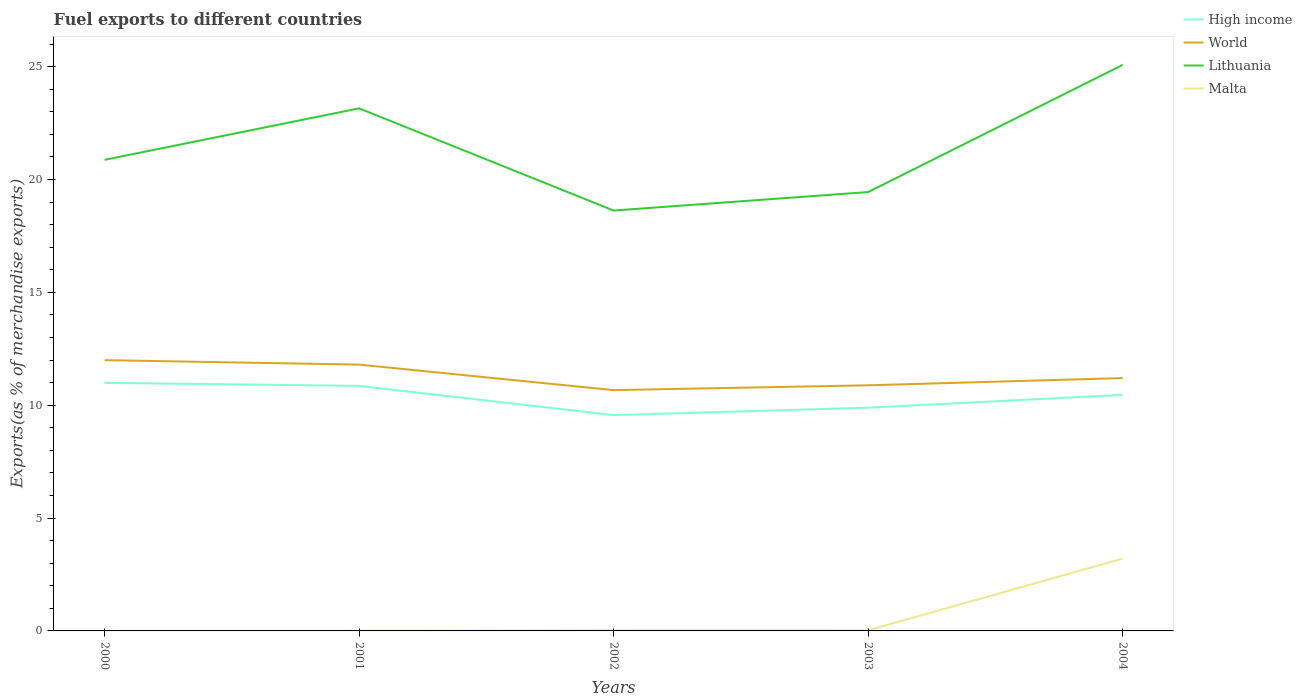How many different coloured lines are there?
Offer a terse response. 4. Across all years, what is the maximum percentage of exports to different countries in Malta?
Keep it short and to the point. 3.27668183292656e-5. In which year was the percentage of exports to different countries in Malta maximum?
Give a very brief answer. 2000. What is the total percentage of exports to different countries in Malta in the graph?
Ensure brevity in your answer.  -3.18. What is the difference between the highest and the second highest percentage of exports to different countries in Malta?
Your answer should be compact. 3.21. What is the difference between the highest and the lowest percentage of exports to different countries in High income?
Make the answer very short. 3. How many lines are there?
Offer a terse response. 4. Where does the legend appear in the graph?
Keep it short and to the point. Top right. How many legend labels are there?
Make the answer very short. 4. What is the title of the graph?
Make the answer very short. Fuel exports to different countries. What is the label or title of the X-axis?
Keep it short and to the point. Years. What is the label or title of the Y-axis?
Provide a succinct answer. Exports(as % of merchandise exports). What is the Exports(as % of merchandise exports) of High income in 2000?
Provide a short and direct response. 10.99. What is the Exports(as % of merchandise exports) of World in 2000?
Your answer should be compact. 12. What is the Exports(as % of merchandise exports) in Lithuania in 2000?
Your response must be concise. 20.87. What is the Exports(as % of merchandise exports) in Malta in 2000?
Provide a short and direct response. 3.27668183292656e-5. What is the Exports(as % of merchandise exports) in High income in 2001?
Your response must be concise. 10.86. What is the Exports(as % of merchandise exports) in World in 2001?
Provide a succinct answer. 11.8. What is the Exports(as % of merchandise exports) of Lithuania in 2001?
Provide a succinct answer. 23.15. What is the Exports(as % of merchandise exports) in Malta in 2001?
Offer a very short reply. 0. What is the Exports(as % of merchandise exports) in High income in 2002?
Your response must be concise. 9.56. What is the Exports(as % of merchandise exports) in World in 2002?
Your response must be concise. 10.67. What is the Exports(as % of merchandise exports) in Lithuania in 2002?
Your response must be concise. 18.62. What is the Exports(as % of merchandise exports) of Malta in 2002?
Make the answer very short. 0.03. What is the Exports(as % of merchandise exports) in High income in 2003?
Make the answer very short. 9.89. What is the Exports(as % of merchandise exports) in World in 2003?
Ensure brevity in your answer.  10.88. What is the Exports(as % of merchandise exports) in Lithuania in 2003?
Give a very brief answer. 19.44. What is the Exports(as % of merchandise exports) in Malta in 2003?
Your answer should be very brief. 0.03. What is the Exports(as % of merchandise exports) of High income in 2004?
Provide a short and direct response. 10.46. What is the Exports(as % of merchandise exports) in World in 2004?
Ensure brevity in your answer.  11.2. What is the Exports(as % of merchandise exports) in Lithuania in 2004?
Your response must be concise. 25.08. What is the Exports(as % of merchandise exports) of Malta in 2004?
Make the answer very short. 3.21. Across all years, what is the maximum Exports(as % of merchandise exports) in High income?
Your answer should be very brief. 10.99. Across all years, what is the maximum Exports(as % of merchandise exports) of World?
Offer a terse response. 12. Across all years, what is the maximum Exports(as % of merchandise exports) in Lithuania?
Ensure brevity in your answer.  25.08. Across all years, what is the maximum Exports(as % of merchandise exports) in Malta?
Your answer should be compact. 3.21. Across all years, what is the minimum Exports(as % of merchandise exports) in High income?
Offer a terse response. 9.56. Across all years, what is the minimum Exports(as % of merchandise exports) of World?
Your answer should be compact. 10.67. Across all years, what is the minimum Exports(as % of merchandise exports) in Lithuania?
Your answer should be very brief. 18.62. Across all years, what is the minimum Exports(as % of merchandise exports) in Malta?
Ensure brevity in your answer.  3.27668183292656e-5. What is the total Exports(as % of merchandise exports) in High income in the graph?
Offer a terse response. 51.76. What is the total Exports(as % of merchandise exports) in World in the graph?
Provide a succinct answer. 56.55. What is the total Exports(as % of merchandise exports) of Lithuania in the graph?
Provide a succinct answer. 107.17. What is the total Exports(as % of merchandise exports) in Malta in the graph?
Your answer should be very brief. 3.26. What is the difference between the Exports(as % of merchandise exports) of High income in 2000 and that in 2001?
Give a very brief answer. 0.13. What is the difference between the Exports(as % of merchandise exports) of World in 2000 and that in 2001?
Give a very brief answer. 0.2. What is the difference between the Exports(as % of merchandise exports) in Lithuania in 2000 and that in 2001?
Offer a terse response. -2.28. What is the difference between the Exports(as % of merchandise exports) of Malta in 2000 and that in 2001?
Your answer should be very brief. -0. What is the difference between the Exports(as % of merchandise exports) of High income in 2000 and that in 2002?
Offer a terse response. 1.43. What is the difference between the Exports(as % of merchandise exports) in World in 2000 and that in 2002?
Keep it short and to the point. 1.33. What is the difference between the Exports(as % of merchandise exports) of Lithuania in 2000 and that in 2002?
Make the answer very short. 2.25. What is the difference between the Exports(as % of merchandise exports) of Malta in 2000 and that in 2002?
Make the answer very short. -0.03. What is the difference between the Exports(as % of merchandise exports) in High income in 2000 and that in 2003?
Offer a terse response. 1.1. What is the difference between the Exports(as % of merchandise exports) of World in 2000 and that in 2003?
Make the answer very short. 1.11. What is the difference between the Exports(as % of merchandise exports) of Lithuania in 2000 and that in 2003?
Offer a very short reply. 1.43. What is the difference between the Exports(as % of merchandise exports) of Malta in 2000 and that in 2003?
Provide a succinct answer. -0.03. What is the difference between the Exports(as % of merchandise exports) in High income in 2000 and that in 2004?
Offer a very short reply. 0.53. What is the difference between the Exports(as % of merchandise exports) of World in 2000 and that in 2004?
Provide a short and direct response. 0.79. What is the difference between the Exports(as % of merchandise exports) of Lithuania in 2000 and that in 2004?
Provide a succinct answer. -4.21. What is the difference between the Exports(as % of merchandise exports) in Malta in 2000 and that in 2004?
Offer a very short reply. -3.21. What is the difference between the Exports(as % of merchandise exports) of High income in 2001 and that in 2002?
Provide a succinct answer. 1.3. What is the difference between the Exports(as % of merchandise exports) of World in 2001 and that in 2002?
Offer a terse response. 1.13. What is the difference between the Exports(as % of merchandise exports) of Lithuania in 2001 and that in 2002?
Ensure brevity in your answer.  4.53. What is the difference between the Exports(as % of merchandise exports) in Malta in 2001 and that in 2002?
Keep it short and to the point. -0.03. What is the difference between the Exports(as % of merchandise exports) of High income in 2001 and that in 2003?
Provide a short and direct response. 0.97. What is the difference between the Exports(as % of merchandise exports) in World in 2001 and that in 2003?
Offer a very short reply. 0.92. What is the difference between the Exports(as % of merchandise exports) of Lithuania in 2001 and that in 2003?
Keep it short and to the point. 3.71. What is the difference between the Exports(as % of merchandise exports) of Malta in 2001 and that in 2003?
Make the answer very short. -0.02. What is the difference between the Exports(as % of merchandise exports) in High income in 2001 and that in 2004?
Your answer should be compact. 0.4. What is the difference between the Exports(as % of merchandise exports) of World in 2001 and that in 2004?
Provide a short and direct response. 0.6. What is the difference between the Exports(as % of merchandise exports) of Lithuania in 2001 and that in 2004?
Provide a short and direct response. -1.93. What is the difference between the Exports(as % of merchandise exports) in Malta in 2001 and that in 2004?
Give a very brief answer. -3.2. What is the difference between the Exports(as % of merchandise exports) in High income in 2002 and that in 2003?
Your answer should be compact. -0.33. What is the difference between the Exports(as % of merchandise exports) of World in 2002 and that in 2003?
Your response must be concise. -0.21. What is the difference between the Exports(as % of merchandise exports) of Lithuania in 2002 and that in 2003?
Give a very brief answer. -0.82. What is the difference between the Exports(as % of merchandise exports) in Malta in 2002 and that in 2003?
Keep it short and to the point. 0. What is the difference between the Exports(as % of merchandise exports) in High income in 2002 and that in 2004?
Provide a succinct answer. -0.9. What is the difference between the Exports(as % of merchandise exports) of World in 2002 and that in 2004?
Your response must be concise. -0.53. What is the difference between the Exports(as % of merchandise exports) in Lithuania in 2002 and that in 2004?
Offer a terse response. -6.45. What is the difference between the Exports(as % of merchandise exports) of Malta in 2002 and that in 2004?
Your answer should be very brief. -3.18. What is the difference between the Exports(as % of merchandise exports) of High income in 2003 and that in 2004?
Keep it short and to the point. -0.57. What is the difference between the Exports(as % of merchandise exports) of World in 2003 and that in 2004?
Keep it short and to the point. -0.32. What is the difference between the Exports(as % of merchandise exports) of Lithuania in 2003 and that in 2004?
Make the answer very short. -5.63. What is the difference between the Exports(as % of merchandise exports) in Malta in 2003 and that in 2004?
Provide a short and direct response. -3.18. What is the difference between the Exports(as % of merchandise exports) in High income in 2000 and the Exports(as % of merchandise exports) in World in 2001?
Make the answer very short. -0.81. What is the difference between the Exports(as % of merchandise exports) in High income in 2000 and the Exports(as % of merchandise exports) in Lithuania in 2001?
Provide a succinct answer. -12.16. What is the difference between the Exports(as % of merchandise exports) in High income in 2000 and the Exports(as % of merchandise exports) in Malta in 2001?
Make the answer very short. 10.99. What is the difference between the Exports(as % of merchandise exports) in World in 2000 and the Exports(as % of merchandise exports) in Lithuania in 2001?
Offer a terse response. -11.16. What is the difference between the Exports(as % of merchandise exports) in World in 2000 and the Exports(as % of merchandise exports) in Malta in 2001?
Provide a short and direct response. 11.99. What is the difference between the Exports(as % of merchandise exports) in Lithuania in 2000 and the Exports(as % of merchandise exports) in Malta in 2001?
Your answer should be very brief. 20.87. What is the difference between the Exports(as % of merchandise exports) of High income in 2000 and the Exports(as % of merchandise exports) of World in 2002?
Give a very brief answer. 0.32. What is the difference between the Exports(as % of merchandise exports) in High income in 2000 and the Exports(as % of merchandise exports) in Lithuania in 2002?
Provide a succinct answer. -7.63. What is the difference between the Exports(as % of merchandise exports) of High income in 2000 and the Exports(as % of merchandise exports) of Malta in 2002?
Provide a succinct answer. 10.96. What is the difference between the Exports(as % of merchandise exports) in World in 2000 and the Exports(as % of merchandise exports) in Lithuania in 2002?
Ensure brevity in your answer.  -6.63. What is the difference between the Exports(as % of merchandise exports) of World in 2000 and the Exports(as % of merchandise exports) of Malta in 2002?
Offer a terse response. 11.97. What is the difference between the Exports(as % of merchandise exports) in Lithuania in 2000 and the Exports(as % of merchandise exports) in Malta in 2002?
Offer a terse response. 20.84. What is the difference between the Exports(as % of merchandise exports) in High income in 2000 and the Exports(as % of merchandise exports) in World in 2003?
Offer a terse response. 0.11. What is the difference between the Exports(as % of merchandise exports) of High income in 2000 and the Exports(as % of merchandise exports) of Lithuania in 2003?
Provide a succinct answer. -8.45. What is the difference between the Exports(as % of merchandise exports) in High income in 2000 and the Exports(as % of merchandise exports) in Malta in 2003?
Offer a very short reply. 10.96. What is the difference between the Exports(as % of merchandise exports) in World in 2000 and the Exports(as % of merchandise exports) in Lithuania in 2003?
Offer a terse response. -7.45. What is the difference between the Exports(as % of merchandise exports) of World in 2000 and the Exports(as % of merchandise exports) of Malta in 2003?
Your answer should be very brief. 11.97. What is the difference between the Exports(as % of merchandise exports) in Lithuania in 2000 and the Exports(as % of merchandise exports) in Malta in 2003?
Ensure brevity in your answer.  20.84. What is the difference between the Exports(as % of merchandise exports) of High income in 2000 and the Exports(as % of merchandise exports) of World in 2004?
Your answer should be compact. -0.21. What is the difference between the Exports(as % of merchandise exports) in High income in 2000 and the Exports(as % of merchandise exports) in Lithuania in 2004?
Offer a very short reply. -14.09. What is the difference between the Exports(as % of merchandise exports) in High income in 2000 and the Exports(as % of merchandise exports) in Malta in 2004?
Your answer should be very brief. 7.78. What is the difference between the Exports(as % of merchandise exports) of World in 2000 and the Exports(as % of merchandise exports) of Lithuania in 2004?
Keep it short and to the point. -13.08. What is the difference between the Exports(as % of merchandise exports) of World in 2000 and the Exports(as % of merchandise exports) of Malta in 2004?
Offer a very short reply. 8.79. What is the difference between the Exports(as % of merchandise exports) in Lithuania in 2000 and the Exports(as % of merchandise exports) in Malta in 2004?
Make the answer very short. 17.66. What is the difference between the Exports(as % of merchandise exports) of High income in 2001 and the Exports(as % of merchandise exports) of World in 2002?
Ensure brevity in your answer.  0.19. What is the difference between the Exports(as % of merchandise exports) in High income in 2001 and the Exports(as % of merchandise exports) in Lithuania in 2002?
Give a very brief answer. -7.77. What is the difference between the Exports(as % of merchandise exports) in High income in 2001 and the Exports(as % of merchandise exports) in Malta in 2002?
Offer a terse response. 10.83. What is the difference between the Exports(as % of merchandise exports) in World in 2001 and the Exports(as % of merchandise exports) in Lithuania in 2002?
Your answer should be compact. -6.83. What is the difference between the Exports(as % of merchandise exports) of World in 2001 and the Exports(as % of merchandise exports) of Malta in 2002?
Ensure brevity in your answer.  11.77. What is the difference between the Exports(as % of merchandise exports) in Lithuania in 2001 and the Exports(as % of merchandise exports) in Malta in 2002?
Provide a succinct answer. 23.12. What is the difference between the Exports(as % of merchandise exports) of High income in 2001 and the Exports(as % of merchandise exports) of World in 2003?
Offer a terse response. -0.03. What is the difference between the Exports(as % of merchandise exports) in High income in 2001 and the Exports(as % of merchandise exports) in Lithuania in 2003?
Provide a succinct answer. -8.59. What is the difference between the Exports(as % of merchandise exports) in High income in 2001 and the Exports(as % of merchandise exports) in Malta in 2003?
Provide a short and direct response. 10.83. What is the difference between the Exports(as % of merchandise exports) in World in 2001 and the Exports(as % of merchandise exports) in Lithuania in 2003?
Keep it short and to the point. -7.65. What is the difference between the Exports(as % of merchandise exports) in World in 2001 and the Exports(as % of merchandise exports) in Malta in 2003?
Offer a terse response. 11.77. What is the difference between the Exports(as % of merchandise exports) of Lithuania in 2001 and the Exports(as % of merchandise exports) of Malta in 2003?
Offer a terse response. 23.13. What is the difference between the Exports(as % of merchandise exports) of High income in 2001 and the Exports(as % of merchandise exports) of World in 2004?
Offer a terse response. -0.35. What is the difference between the Exports(as % of merchandise exports) of High income in 2001 and the Exports(as % of merchandise exports) of Lithuania in 2004?
Your response must be concise. -14.22. What is the difference between the Exports(as % of merchandise exports) of High income in 2001 and the Exports(as % of merchandise exports) of Malta in 2004?
Offer a terse response. 7.65. What is the difference between the Exports(as % of merchandise exports) of World in 2001 and the Exports(as % of merchandise exports) of Lithuania in 2004?
Offer a terse response. -13.28. What is the difference between the Exports(as % of merchandise exports) in World in 2001 and the Exports(as % of merchandise exports) in Malta in 2004?
Give a very brief answer. 8.59. What is the difference between the Exports(as % of merchandise exports) of Lithuania in 2001 and the Exports(as % of merchandise exports) of Malta in 2004?
Provide a short and direct response. 19.95. What is the difference between the Exports(as % of merchandise exports) of High income in 2002 and the Exports(as % of merchandise exports) of World in 2003?
Your response must be concise. -1.32. What is the difference between the Exports(as % of merchandise exports) in High income in 2002 and the Exports(as % of merchandise exports) in Lithuania in 2003?
Your response must be concise. -9.88. What is the difference between the Exports(as % of merchandise exports) in High income in 2002 and the Exports(as % of merchandise exports) in Malta in 2003?
Provide a succinct answer. 9.53. What is the difference between the Exports(as % of merchandise exports) in World in 2002 and the Exports(as % of merchandise exports) in Lithuania in 2003?
Your response must be concise. -8.78. What is the difference between the Exports(as % of merchandise exports) of World in 2002 and the Exports(as % of merchandise exports) of Malta in 2003?
Provide a succinct answer. 10.64. What is the difference between the Exports(as % of merchandise exports) in Lithuania in 2002 and the Exports(as % of merchandise exports) in Malta in 2003?
Your answer should be very brief. 18.6. What is the difference between the Exports(as % of merchandise exports) in High income in 2002 and the Exports(as % of merchandise exports) in World in 2004?
Your answer should be compact. -1.64. What is the difference between the Exports(as % of merchandise exports) of High income in 2002 and the Exports(as % of merchandise exports) of Lithuania in 2004?
Keep it short and to the point. -15.52. What is the difference between the Exports(as % of merchandise exports) of High income in 2002 and the Exports(as % of merchandise exports) of Malta in 2004?
Make the answer very short. 6.35. What is the difference between the Exports(as % of merchandise exports) of World in 2002 and the Exports(as % of merchandise exports) of Lithuania in 2004?
Ensure brevity in your answer.  -14.41. What is the difference between the Exports(as % of merchandise exports) of World in 2002 and the Exports(as % of merchandise exports) of Malta in 2004?
Provide a short and direct response. 7.46. What is the difference between the Exports(as % of merchandise exports) of Lithuania in 2002 and the Exports(as % of merchandise exports) of Malta in 2004?
Make the answer very short. 15.42. What is the difference between the Exports(as % of merchandise exports) in High income in 2003 and the Exports(as % of merchandise exports) in World in 2004?
Give a very brief answer. -1.31. What is the difference between the Exports(as % of merchandise exports) in High income in 2003 and the Exports(as % of merchandise exports) in Lithuania in 2004?
Give a very brief answer. -15.19. What is the difference between the Exports(as % of merchandise exports) of High income in 2003 and the Exports(as % of merchandise exports) of Malta in 2004?
Offer a very short reply. 6.68. What is the difference between the Exports(as % of merchandise exports) of World in 2003 and the Exports(as % of merchandise exports) of Lithuania in 2004?
Ensure brevity in your answer.  -14.2. What is the difference between the Exports(as % of merchandise exports) of World in 2003 and the Exports(as % of merchandise exports) of Malta in 2004?
Make the answer very short. 7.68. What is the difference between the Exports(as % of merchandise exports) in Lithuania in 2003 and the Exports(as % of merchandise exports) in Malta in 2004?
Give a very brief answer. 16.24. What is the average Exports(as % of merchandise exports) in High income per year?
Your response must be concise. 10.35. What is the average Exports(as % of merchandise exports) in World per year?
Provide a short and direct response. 11.31. What is the average Exports(as % of merchandise exports) of Lithuania per year?
Make the answer very short. 21.43. What is the average Exports(as % of merchandise exports) of Malta per year?
Offer a terse response. 0.65. In the year 2000, what is the difference between the Exports(as % of merchandise exports) of High income and Exports(as % of merchandise exports) of World?
Your answer should be very brief. -1.01. In the year 2000, what is the difference between the Exports(as % of merchandise exports) of High income and Exports(as % of merchandise exports) of Lithuania?
Your answer should be compact. -9.88. In the year 2000, what is the difference between the Exports(as % of merchandise exports) in High income and Exports(as % of merchandise exports) in Malta?
Make the answer very short. 10.99. In the year 2000, what is the difference between the Exports(as % of merchandise exports) in World and Exports(as % of merchandise exports) in Lithuania?
Your answer should be very brief. -8.88. In the year 2000, what is the difference between the Exports(as % of merchandise exports) in World and Exports(as % of merchandise exports) in Malta?
Keep it short and to the point. 12. In the year 2000, what is the difference between the Exports(as % of merchandise exports) in Lithuania and Exports(as % of merchandise exports) in Malta?
Offer a very short reply. 20.87. In the year 2001, what is the difference between the Exports(as % of merchandise exports) in High income and Exports(as % of merchandise exports) in World?
Your answer should be compact. -0.94. In the year 2001, what is the difference between the Exports(as % of merchandise exports) of High income and Exports(as % of merchandise exports) of Lithuania?
Offer a very short reply. -12.3. In the year 2001, what is the difference between the Exports(as % of merchandise exports) in High income and Exports(as % of merchandise exports) in Malta?
Your answer should be very brief. 10.85. In the year 2001, what is the difference between the Exports(as % of merchandise exports) in World and Exports(as % of merchandise exports) in Lithuania?
Offer a terse response. -11.35. In the year 2001, what is the difference between the Exports(as % of merchandise exports) of World and Exports(as % of merchandise exports) of Malta?
Ensure brevity in your answer.  11.8. In the year 2001, what is the difference between the Exports(as % of merchandise exports) of Lithuania and Exports(as % of merchandise exports) of Malta?
Give a very brief answer. 23.15. In the year 2002, what is the difference between the Exports(as % of merchandise exports) in High income and Exports(as % of merchandise exports) in World?
Ensure brevity in your answer.  -1.11. In the year 2002, what is the difference between the Exports(as % of merchandise exports) in High income and Exports(as % of merchandise exports) in Lithuania?
Keep it short and to the point. -9.06. In the year 2002, what is the difference between the Exports(as % of merchandise exports) in High income and Exports(as % of merchandise exports) in Malta?
Your response must be concise. 9.53. In the year 2002, what is the difference between the Exports(as % of merchandise exports) of World and Exports(as % of merchandise exports) of Lithuania?
Keep it short and to the point. -7.96. In the year 2002, what is the difference between the Exports(as % of merchandise exports) of World and Exports(as % of merchandise exports) of Malta?
Provide a short and direct response. 10.64. In the year 2002, what is the difference between the Exports(as % of merchandise exports) of Lithuania and Exports(as % of merchandise exports) of Malta?
Provide a succinct answer. 18.6. In the year 2003, what is the difference between the Exports(as % of merchandise exports) of High income and Exports(as % of merchandise exports) of World?
Give a very brief answer. -0.99. In the year 2003, what is the difference between the Exports(as % of merchandise exports) of High income and Exports(as % of merchandise exports) of Lithuania?
Your response must be concise. -9.55. In the year 2003, what is the difference between the Exports(as % of merchandise exports) in High income and Exports(as % of merchandise exports) in Malta?
Give a very brief answer. 9.86. In the year 2003, what is the difference between the Exports(as % of merchandise exports) in World and Exports(as % of merchandise exports) in Lithuania?
Your answer should be very brief. -8.56. In the year 2003, what is the difference between the Exports(as % of merchandise exports) in World and Exports(as % of merchandise exports) in Malta?
Make the answer very short. 10.86. In the year 2003, what is the difference between the Exports(as % of merchandise exports) of Lithuania and Exports(as % of merchandise exports) of Malta?
Your answer should be very brief. 19.42. In the year 2004, what is the difference between the Exports(as % of merchandise exports) in High income and Exports(as % of merchandise exports) in World?
Make the answer very short. -0.75. In the year 2004, what is the difference between the Exports(as % of merchandise exports) of High income and Exports(as % of merchandise exports) of Lithuania?
Make the answer very short. -14.62. In the year 2004, what is the difference between the Exports(as % of merchandise exports) of High income and Exports(as % of merchandise exports) of Malta?
Your response must be concise. 7.25. In the year 2004, what is the difference between the Exports(as % of merchandise exports) in World and Exports(as % of merchandise exports) in Lithuania?
Ensure brevity in your answer.  -13.88. In the year 2004, what is the difference between the Exports(as % of merchandise exports) of World and Exports(as % of merchandise exports) of Malta?
Make the answer very short. 8. In the year 2004, what is the difference between the Exports(as % of merchandise exports) in Lithuania and Exports(as % of merchandise exports) in Malta?
Provide a short and direct response. 21.87. What is the ratio of the Exports(as % of merchandise exports) in High income in 2000 to that in 2001?
Ensure brevity in your answer.  1.01. What is the ratio of the Exports(as % of merchandise exports) of World in 2000 to that in 2001?
Give a very brief answer. 1.02. What is the ratio of the Exports(as % of merchandise exports) of Lithuania in 2000 to that in 2001?
Keep it short and to the point. 0.9. What is the ratio of the Exports(as % of merchandise exports) in Malta in 2000 to that in 2001?
Your answer should be very brief. 0.01. What is the ratio of the Exports(as % of merchandise exports) in High income in 2000 to that in 2002?
Your response must be concise. 1.15. What is the ratio of the Exports(as % of merchandise exports) of World in 2000 to that in 2002?
Give a very brief answer. 1.12. What is the ratio of the Exports(as % of merchandise exports) of Lithuania in 2000 to that in 2002?
Make the answer very short. 1.12. What is the ratio of the Exports(as % of merchandise exports) in Malta in 2000 to that in 2002?
Provide a short and direct response. 0. What is the ratio of the Exports(as % of merchandise exports) in High income in 2000 to that in 2003?
Make the answer very short. 1.11. What is the ratio of the Exports(as % of merchandise exports) of World in 2000 to that in 2003?
Make the answer very short. 1.1. What is the ratio of the Exports(as % of merchandise exports) of Lithuania in 2000 to that in 2003?
Make the answer very short. 1.07. What is the ratio of the Exports(as % of merchandise exports) in Malta in 2000 to that in 2003?
Give a very brief answer. 0. What is the ratio of the Exports(as % of merchandise exports) in High income in 2000 to that in 2004?
Make the answer very short. 1.05. What is the ratio of the Exports(as % of merchandise exports) of World in 2000 to that in 2004?
Ensure brevity in your answer.  1.07. What is the ratio of the Exports(as % of merchandise exports) in Lithuania in 2000 to that in 2004?
Your answer should be compact. 0.83. What is the ratio of the Exports(as % of merchandise exports) of Malta in 2000 to that in 2004?
Offer a terse response. 0. What is the ratio of the Exports(as % of merchandise exports) of High income in 2001 to that in 2002?
Give a very brief answer. 1.14. What is the ratio of the Exports(as % of merchandise exports) of World in 2001 to that in 2002?
Offer a terse response. 1.11. What is the ratio of the Exports(as % of merchandise exports) of Lithuania in 2001 to that in 2002?
Provide a succinct answer. 1.24. What is the ratio of the Exports(as % of merchandise exports) in Malta in 2001 to that in 2002?
Offer a very short reply. 0.08. What is the ratio of the Exports(as % of merchandise exports) of High income in 2001 to that in 2003?
Provide a short and direct response. 1.1. What is the ratio of the Exports(as % of merchandise exports) of World in 2001 to that in 2003?
Keep it short and to the point. 1.08. What is the ratio of the Exports(as % of merchandise exports) of Lithuania in 2001 to that in 2003?
Provide a short and direct response. 1.19. What is the ratio of the Exports(as % of merchandise exports) in Malta in 2001 to that in 2003?
Make the answer very short. 0.09. What is the ratio of the Exports(as % of merchandise exports) of High income in 2001 to that in 2004?
Offer a terse response. 1.04. What is the ratio of the Exports(as % of merchandise exports) of World in 2001 to that in 2004?
Provide a short and direct response. 1.05. What is the ratio of the Exports(as % of merchandise exports) of Lithuania in 2001 to that in 2004?
Give a very brief answer. 0.92. What is the ratio of the Exports(as % of merchandise exports) in Malta in 2001 to that in 2004?
Your answer should be compact. 0. What is the ratio of the Exports(as % of merchandise exports) in High income in 2002 to that in 2003?
Keep it short and to the point. 0.97. What is the ratio of the Exports(as % of merchandise exports) in World in 2002 to that in 2003?
Offer a very short reply. 0.98. What is the ratio of the Exports(as % of merchandise exports) in Lithuania in 2002 to that in 2003?
Provide a short and direct response. 0.96. What is the ratio of the Exports(as % of merchandise exports) in Malta in 2002 to that in 2003?
Provide a succinct answer. 1.09. What is the ratio of the Exports(as % of merchandise exports) of High income in 2002 to that in 2004?
Your answer should be very brief. 0.91. What is the ratio of the Exports(as % of merchandise exports) in World in 2002 to that in 2004?
Provide a short and direct response. 0.95. What is the ratio of the Exports(as % of merchandise exports) of Lithuania in 2002 to that in 2004?
Make the answer very short. 0.74. What is the ratio of the Exports(as % of merchandise exports) of Malta in 2002 to that in 2004?
Provide a short and direct response. 0.01. What is the ratio of the Exports(as % of merchandise exports) in High income in 2003 to that in 2004?
Give a very brief answer. 0.95. What is the ratio of the Exports(as % of merchandise exports) in World in 2003 to that in 2004?
Your answer should be compact. 0.97. What is the ratio of the Exports(as % of merchandise exports) in Lithuania in 2003 to that in 2004?
Provide a succinct answer. 0.78. What is the ratio of the Exports(as % of merchandise exports) of Malta in 2003 to that in 2004?
Keep it short and to the point. 0.01. What is the difference between the highest and the second highest Exports(as % of merchandise exports) of High income?
Provide a short and direct response. 0.13. What is the difference between the highest and the second highest Exports(as % of merchandise exports) in World?
Make the answer very short. 0.2. What is the difference between the highest and the second highest Exports(as % of merchandise exports) in Lithuania?
Ensure brevity in your answer.  1.93. What is the difference between the highest and the second highest Exports(as % of merchandise exports) of Malta?
Your answer should be very brief. 3.18. What is the difference between the highest and the lowest Exports(as % of merchandise exports) of High income?
Your answer should be very brief. 1.43. What is the difference between the highest and the lowest Exports(as % of merchandise exports) of World?
Provide a short and direct response. 1.33. What is the difference between the highest and the lowest Exports(as % of merchandise exports) in Lithuania?
Your answer should be compact. 6.45. What is the difference between the highest and the lowest Exports(as % of merchandise exports) in Malta?
Provide a succinct answer. 3.21. 